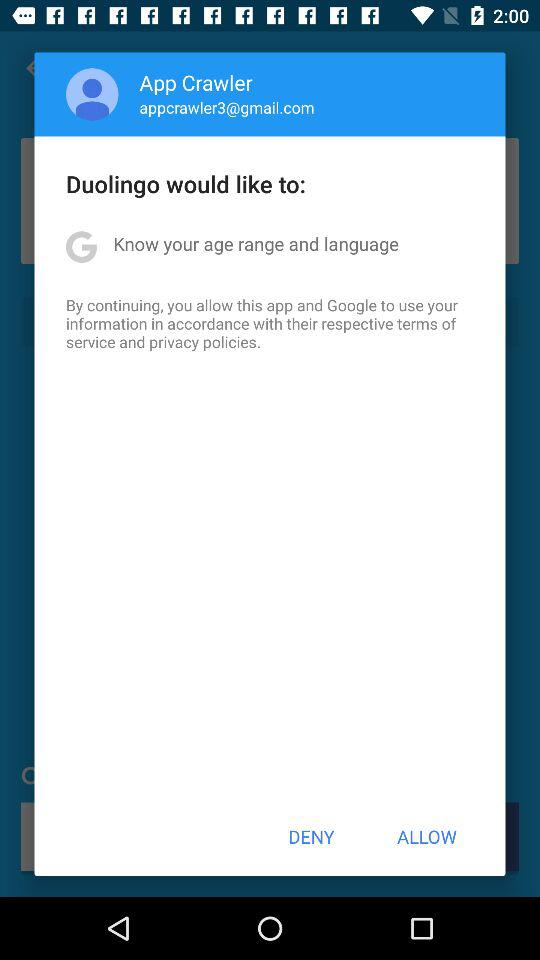What is the email address of the user? The email address of the user is appcrawler3@gmail.com. 